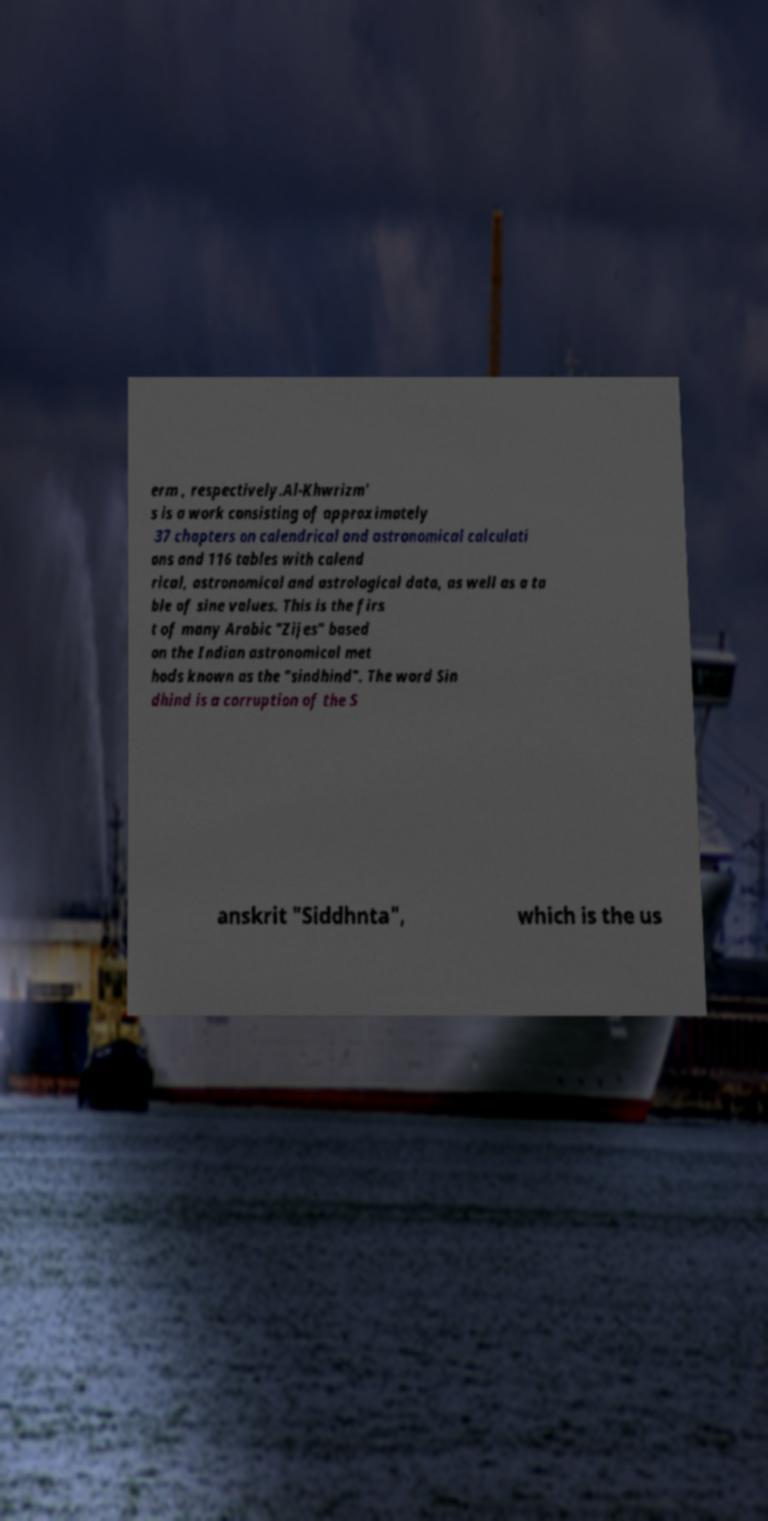For documentation purposes, I need the text within this image transcribed. Could you provide that? erm , respectively.Al-Khwrizm' s is a work consisting of approximately 37 chapters on calendrical and astronomical calculati ons and 116 tables with calend rical, astronomical and astrological data, as well as a ta ble of sine values. This is the firs t of many Arabic "Zijes" based on the Indian astronomical met hods known as the "sindhind". The word Sin dhind is a corruption of the S anskrit "Siddhnta", which is the us 